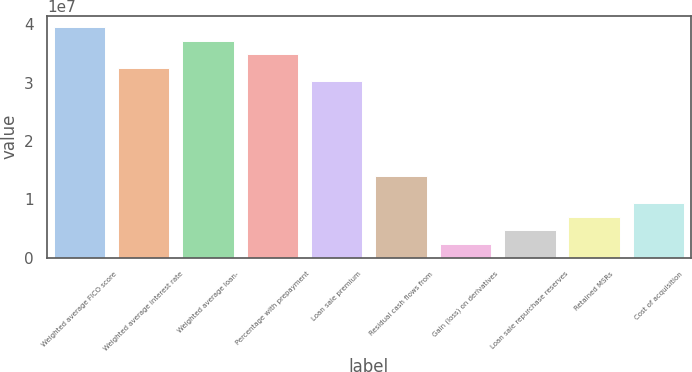Convert chart to OTSL. <chart><loc_0><loc_0><loc_500><loc_500><bar_chart><fcel>Weighted average FICO score<fcel>Weighted average interest rate<fcel>Weighted average loan-<fcel>Percentage with prepayment<fcel>Loan sale premium<fcel>Residual cash flows from<fcel>Gain (loss) on derivatives<fcel>Loan sale repurchase reserves<fcel>Retained MSRs<fcel>Cost of acquisition<nl><fcel>3.94994e+07<fcel>3.25289e+07<fcel>3.71759e+07<fcel>3.48524e+07<fcel>3.02054e+07<fcel>1.3941e+07<fcel>2.32349e+06<fcel>4.64699e+06<fcel>6.97048e+06<fcel>9.29397e+06<nl></chart> 